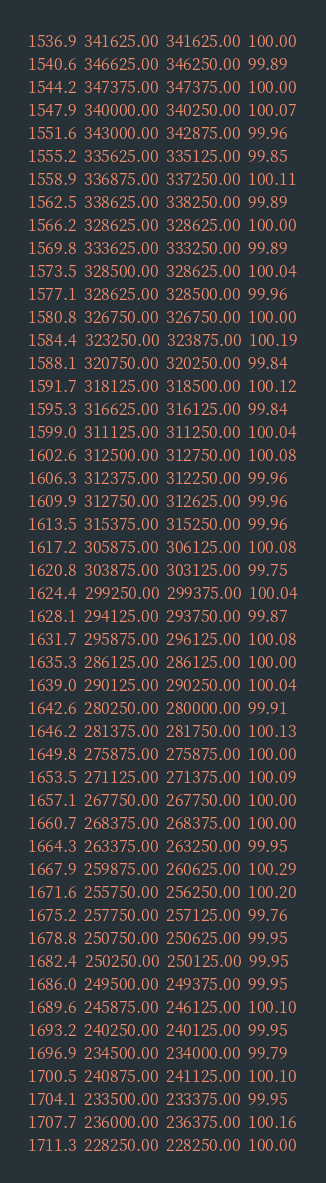Convert code to text. <code><loc_0><loc_0><loc_500><loc_500><_SML_>1536.9  341625.00  341625.00  100.00
1540.6  346625.00  346250.00  99.89
1544.2  347375.00  347375.00  100.00
1547.9  340000.00  340250.00  100.07
1551.6  343000.00  342875.00  99.96
1555.2  335625.00  335125.00  99.85
1558.9  336875.00  337250.00  100.11
1562.5  338625.00  338250.00  99.89
1566.2  328625.00  328625.00  100.00
1569.8  333625.00  333250.00  99.89
1573.5  328500.00  328625.00  100.04
1577.1  328625.00  328500.00  99.96
1580.8  326750.00  326750.00  100.00
1584.4  323250.00  323875.00  100.19
1588.1  320750.00  320250.00  99.84
1591.7  318125.00  318500.00  100.12
1595.3  316625.00  316125.00  99.84
1599.0  311125.00  311250.00  100.04
1602.6  312500.00  312750.00  100.08
1606.3  312375.00  312250.00  99.96
1609.9  312750.00  312625.00  99.96
1613.5  315375.00  315250.00  99.96
1617.2  305875.00  306125.00  100.08
1620.8  303875.00  303125.00  99.75
1624.4  299250.00  299375.00  100.04
1628.1  294125.00  293750.00  99.87
1631.7  295875.00  296125.00  100.08
1635.3  286125.00  286125.00  100.00
1639.0  290125.00  290250.00  100.04
1642.6  280250.00  280000.00  99.91
1646.2  281375.00  281750.00  100.13
1649.8  275875.00  275875.00  100.00
1653.5  271125.00  271375.00  100.09
1657.1  267750.00  267750.00  100.00
1660.7  268375.00  268375.00  100.00
1664.3  263375.00  263250.00  99.95
1667.9  259875.00  260625.00  100.29
1671.6  255750.00  256250.00  100.20
1675.2  257750.00  257125.00  99.76
1678.8  250750.00  250625.00  99.95
1682.4  250250.00  250125.00  99.95
1686.0  249500.00  249375.00  99.95
1689.6  245875.00  246125.00  100.10
1693.2  240250.00  240125.00  99.95
1696.9  234500.00  234000.00  99.79
1700.5  240875.00  241125.00  100.10
1704.1  233500.00  233375.00  99.95
1707.7  236000.00  236375.00  100.16
1711.3  228250.00  228250.00  100.00</code> 